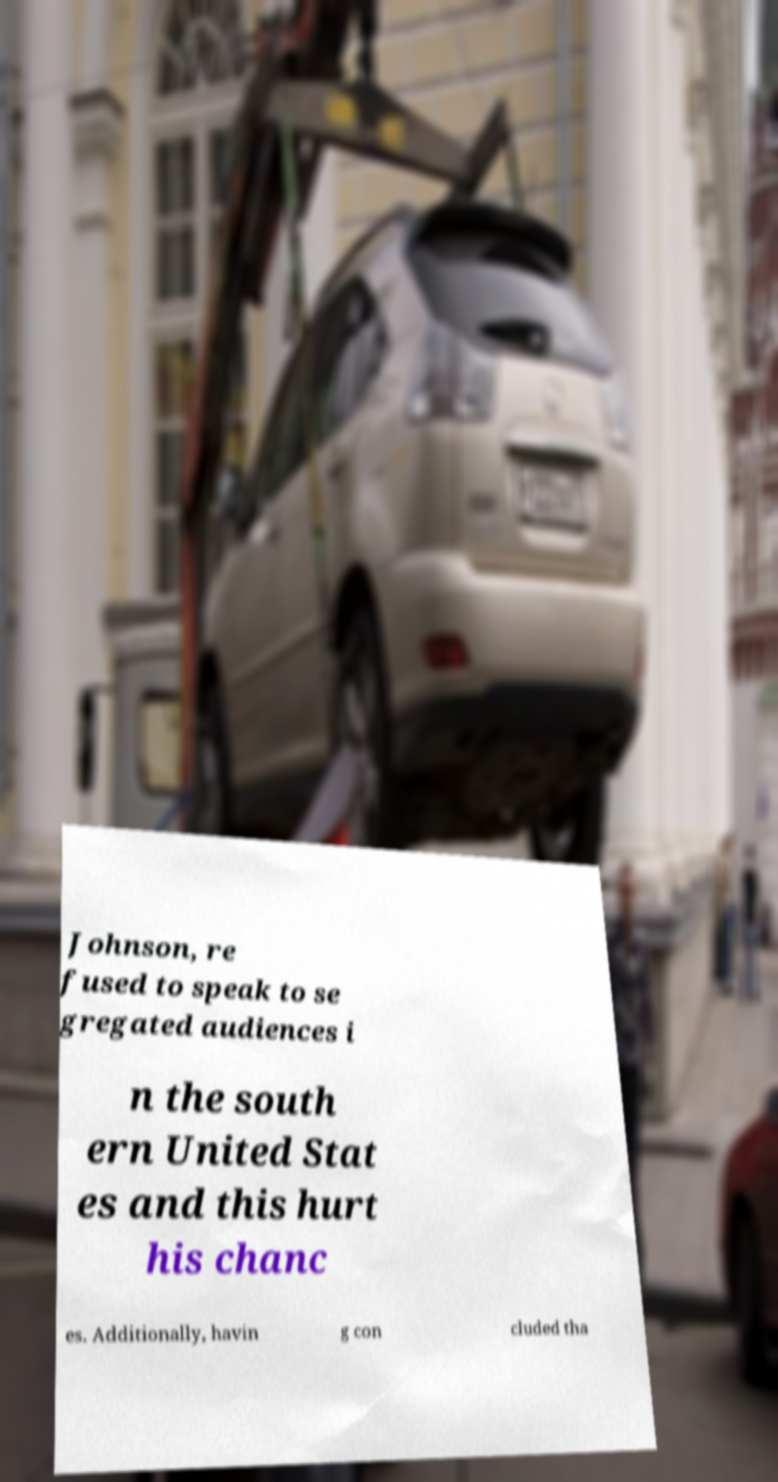What messages or text are displayed in this image? I need them in a readable, typed format. Johnson, re fused to speak to se gregated audiences i n the south ern United Stat es and this hurt his chanc es. Additionally, havin g con cluded tha 